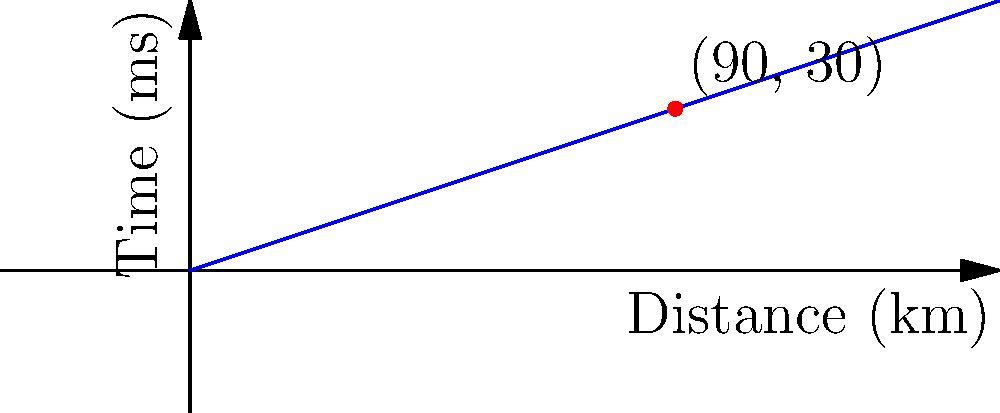In a fiber optic network, data packets travel at the speed of light through cables. If a data packet takes 30 milliseconds to travel 90 kilometers, what is the velocity of the data packet in km/s? How does this compare to the speed of light in a vacuum (approximately 300,000 km/s)? To solve this problem, let's follow these steps:

1. Calculate the velocity of the data packet:
   - Distance traveled = 90 km
   - Time taken = 30 ms = 0.03 s
   - Velocity = Distance / Time
   
   $v = \frac{90 \text{ km}}{0.03 \text{ s}} = 3000 \text{ km/s}$

2. Compare to the speed of light in a vacuum:
   - Speed of light in vacuum ≈ 300,000 km/s
   - Ratio = (Velocity of data packet) / (Speed of light in vacuum)
   
   $\text{Ratio} = \frac{3000 \text{ km/s}}{300,000 \text{ km/s}} = 0.01 = 1\%$

3. Interpret the result:
   The data packet travels at 3000 km/s, which is 1% of the speed of light in a vacuum. This reduced speed is due to the refractive index of the fiber optic material, which slows down the light compared to its speed in a vacuum.

For a social media manager concerned with data security, understanding the speed of data transmission is crucial for assessing potential vulnerabilities and optimizing data transfer protocols.
Answer: 3000 km/s, 1% of light speed in vacuum 